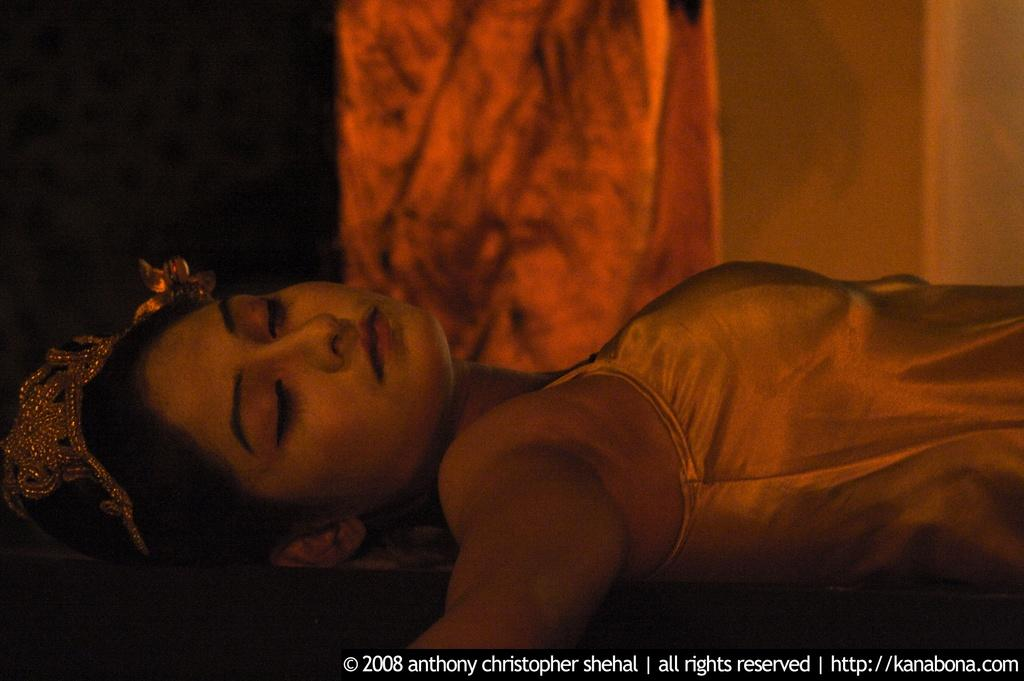What is the woman in the image doing? The woman is laying down in the image. What can be seen in the background of the image? There appears to be a pillar in the background of the image. Is there any additional information or branding on the image? Yes, the image has a watermark. What type of insurance policy is being advertised in the image? There is no insurance policy being advertised in the image; it features a woman laying down and a pillar in the background. What color is the silver channel in the image? There is no silver channel present in the image. 